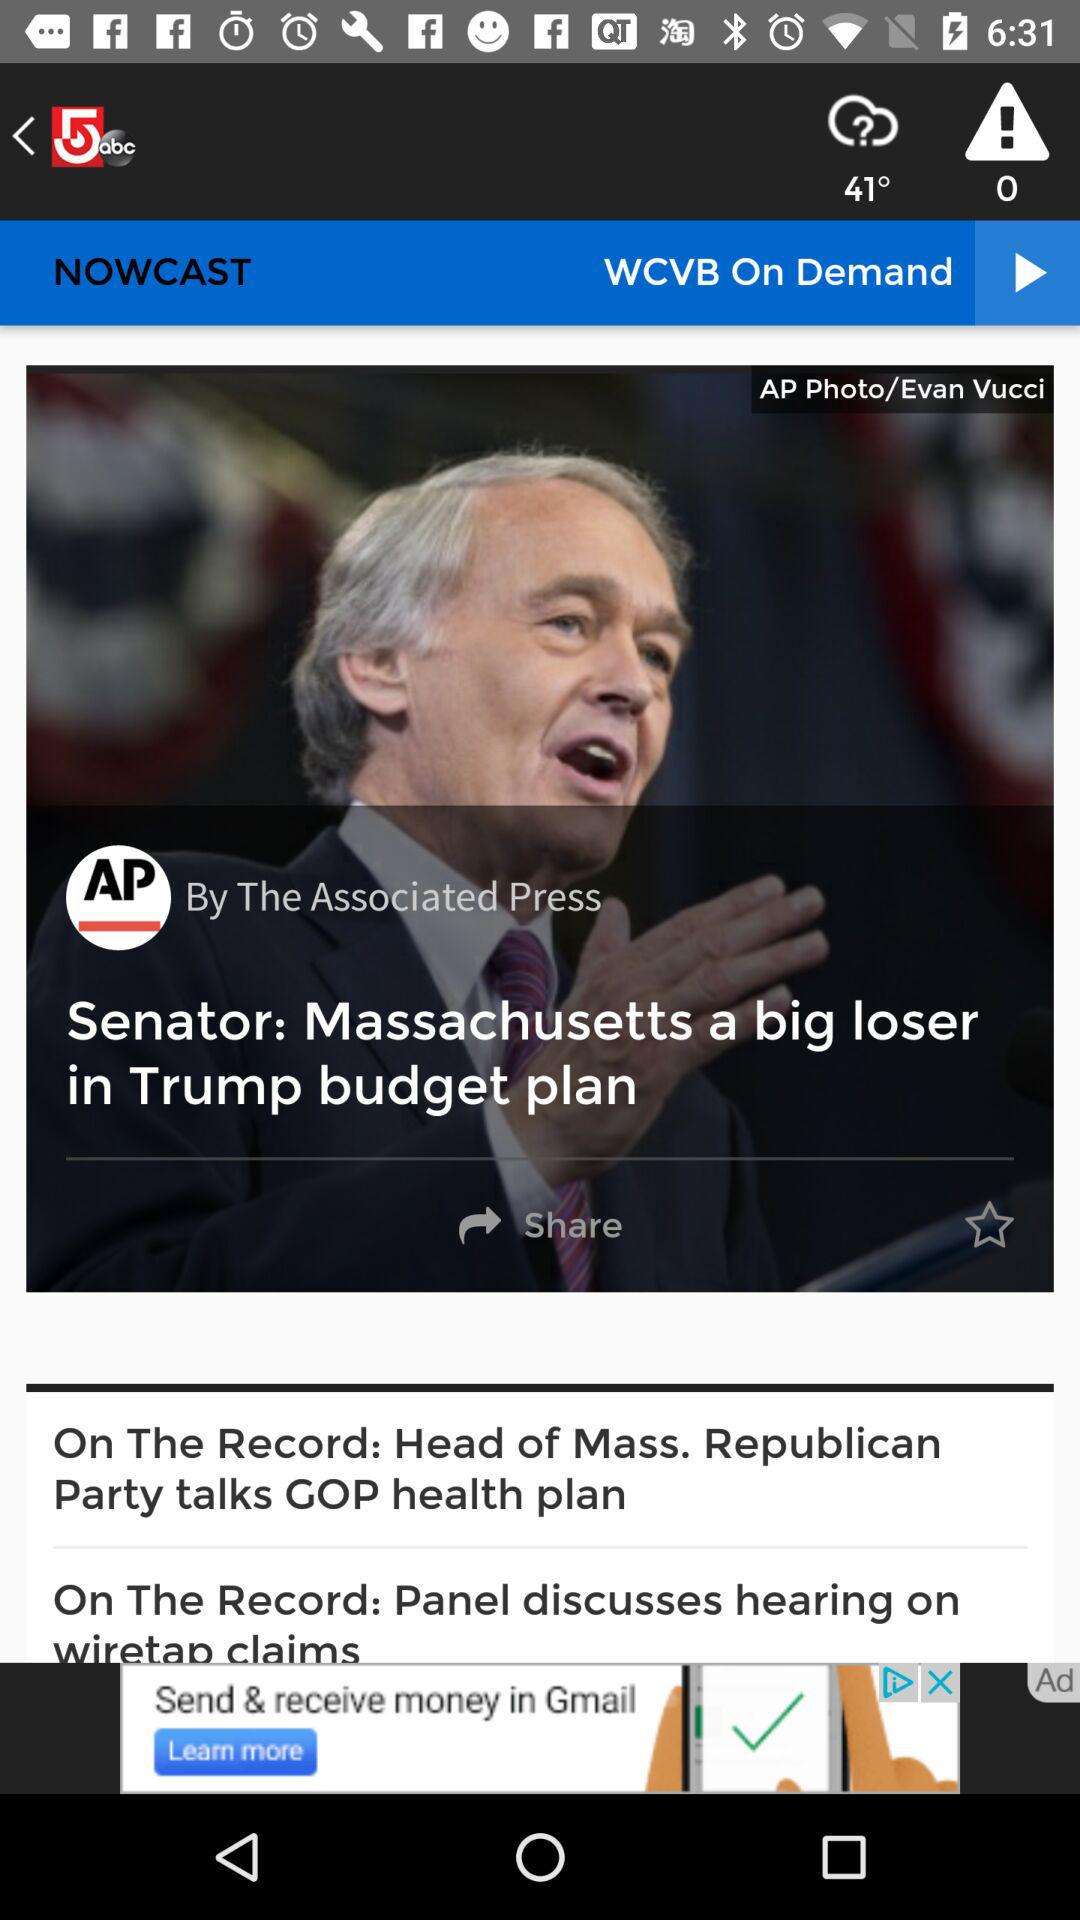What's the application name? The application name is "WCVB". 